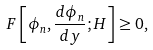Convert formula to latex. <formula><loc_0><loc_0><loc_500><loc_500>F \left [ \phi _ { n } , \frac { d \phi _ { n } } { d y } ; H \right ] \geq 0 ,</formula> 